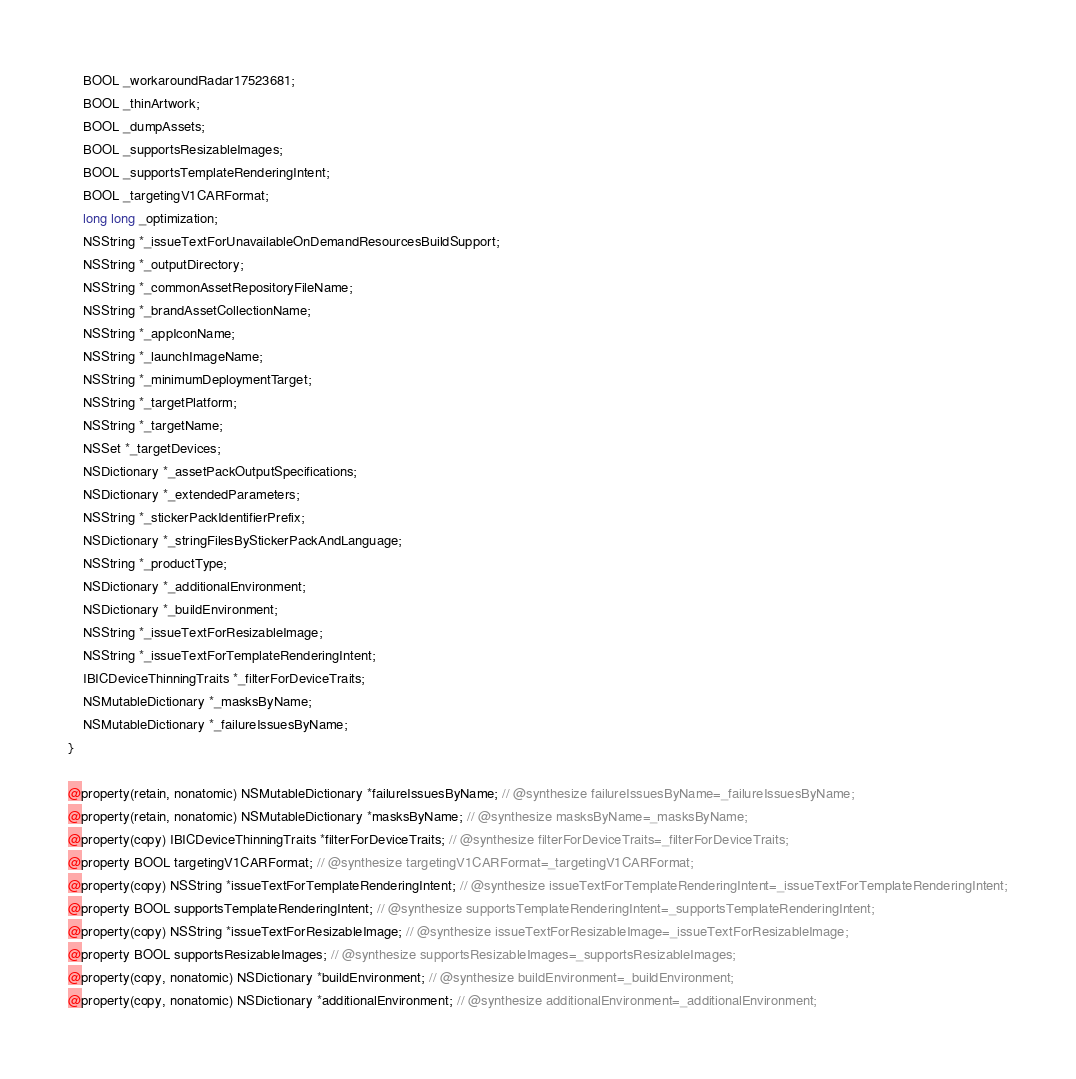Convert code to text. <code><loc_0><loc_0><loc_500><loc_500><_C_>    BOOL _workaroundRadar17523681;
    BOOL _thinArtwork;
    BOOL _dumpAssets;
    BOOL _supportsResizableImages;
    BOOL _supportsTemplateRenderingIntent;
    BOOL _targetingV1CARFormat;
    long long _optimization;
    NSString *_issueTextForUnavailableOnDemandResourcesBuildSupport;
    NSString *_outputDirectory;
    NSString *_commonAssetRepositoryFileName;
    NSString *_brandAssetCollectionName;
    NSString *_appIconName;
    NSString *_launchImageName;
    NSString *_minimumDeploymentTarget;
    NSString *_targetPlatform;
    NSString *_targetName;
    NSSet *_targetDevices;
    NSDictionary *_assetPackOutputSpecifications;
    NSDictionary *_extendedParameters;
    NSString *_stickerPackIdentifierPrefix;
    NSDictionary *_stringFilesByStickerPackAndLanguage;
    NSString *_productType;
    NSDictionary *_additionalEnvironment;
    NSDictionary *_buildEnvironment;
    NSString *_issueTextForResizableImage;
    NSString *_issueTextForTemplateRenderingIntent;
    IBICDeviceThinningTraits *_filterForDeviceTraits;
    NSMutableDictionary *_masksByName;
    NSMutableDictionary *_failureIssuesByName;
}

@property(retain, nonatomic) NSMutableDictionary *failureIssuesByName; // @synthesize failureIssuesByName=_failureIssuesByName;
@property(retain, nonatomic) NSMutableDictionary *masksByName; // @synthesize masksByName=_masksByName;
@property(copy) IBICDeviceThinningTraits *filterForDeviceTraits; // @synthesize filterForDeviceTraits=_filterForDeviceTraits;
@property BOOL targetingV1CARFormat; // @synthesize targetingV1CARFormat=_targetingV1CARFormat;
@property(copy) NSString *issueTextForTemplateRenderingIntent; // @synthesize issueTextForTemplateRenderingIntent=_issueTextForTemplateRenderingIntent;
@property BOOL supportsTemplateRenderingIntent; // @synthesize supportsTemplateRenderingIntent=_supportsTemplateRenderingIntent;
@property(copy) NSString *issueTextForResizableImage; // @synthesize issueTextForResizableImage=_issueTextForResizableImage;
@property BOOL supportsResizableImages; // @synthesize supportsResizableImages=_supportsResizableImages;
@property(copy, nonatomic) NSDictionary *buildEnvironment; // @synthesize buildEnvironment=_buildEnvironment;
@property(copy, nonatomic) NSDictionary *additionalEnvironment; // @synthesize additionalEnvironment=_additionalEnvironment;</code> 